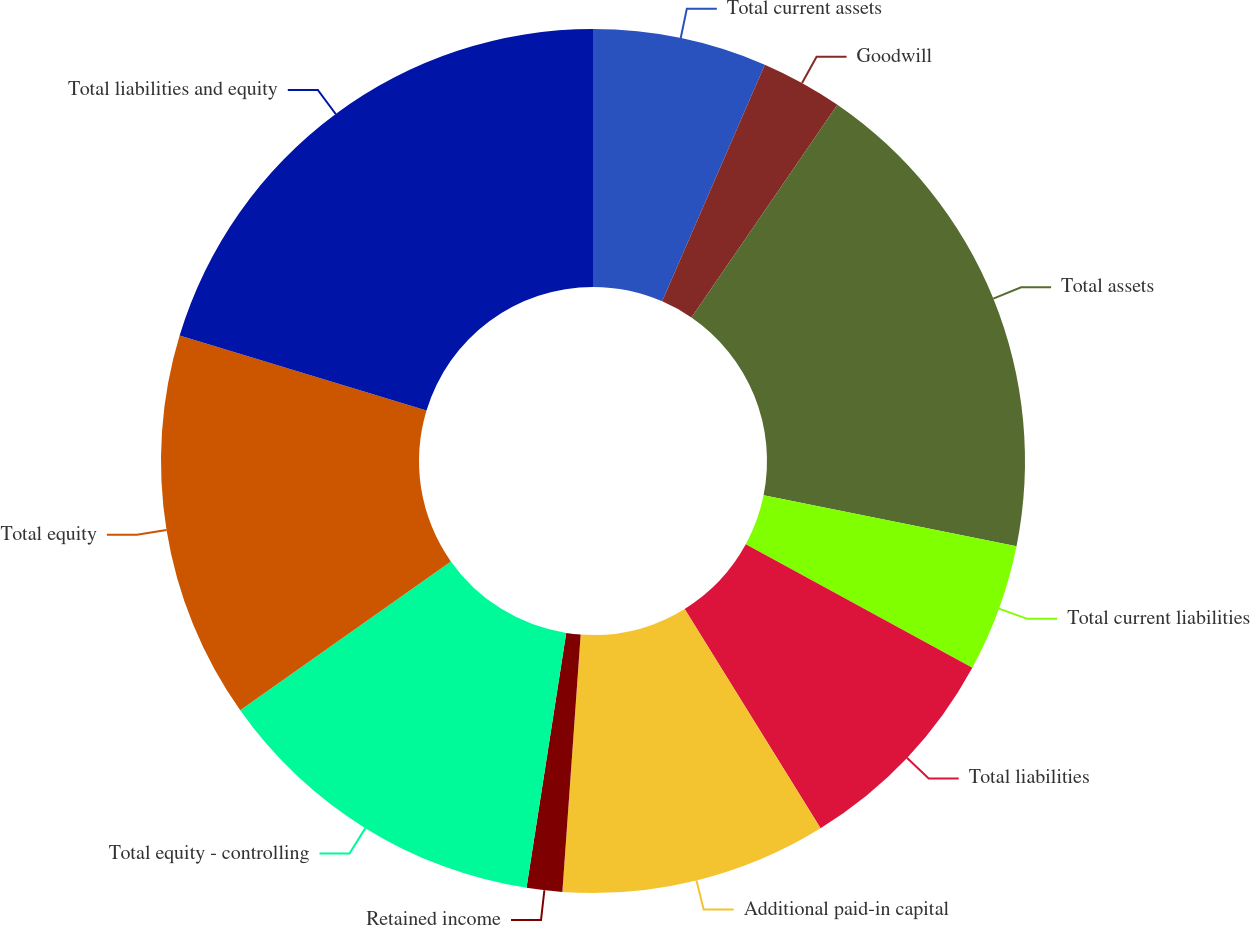<chart> <loc_0><loc_0><loc_500><loc_500><pie_chart><fcel>Total current assets<fcel>Goodwill<fcel>Total assets<fcel>Total current liabilities<fcel>Total liabilities<fcel>Additional paid-in capital<fcel>Retained income<fcel>Total equity - controlling<fcel>Total equity<fcel>Total liabilities and equity<nl><fcel>6.51%<fcel>3.06%<fcel>18.59%<fcel>4.78%<fcel>8.23%<fcel>9.96%<fcel>1.33%<fcel>12.75%<fcel>14.48%<fcel>20.31%<nl></chart> 